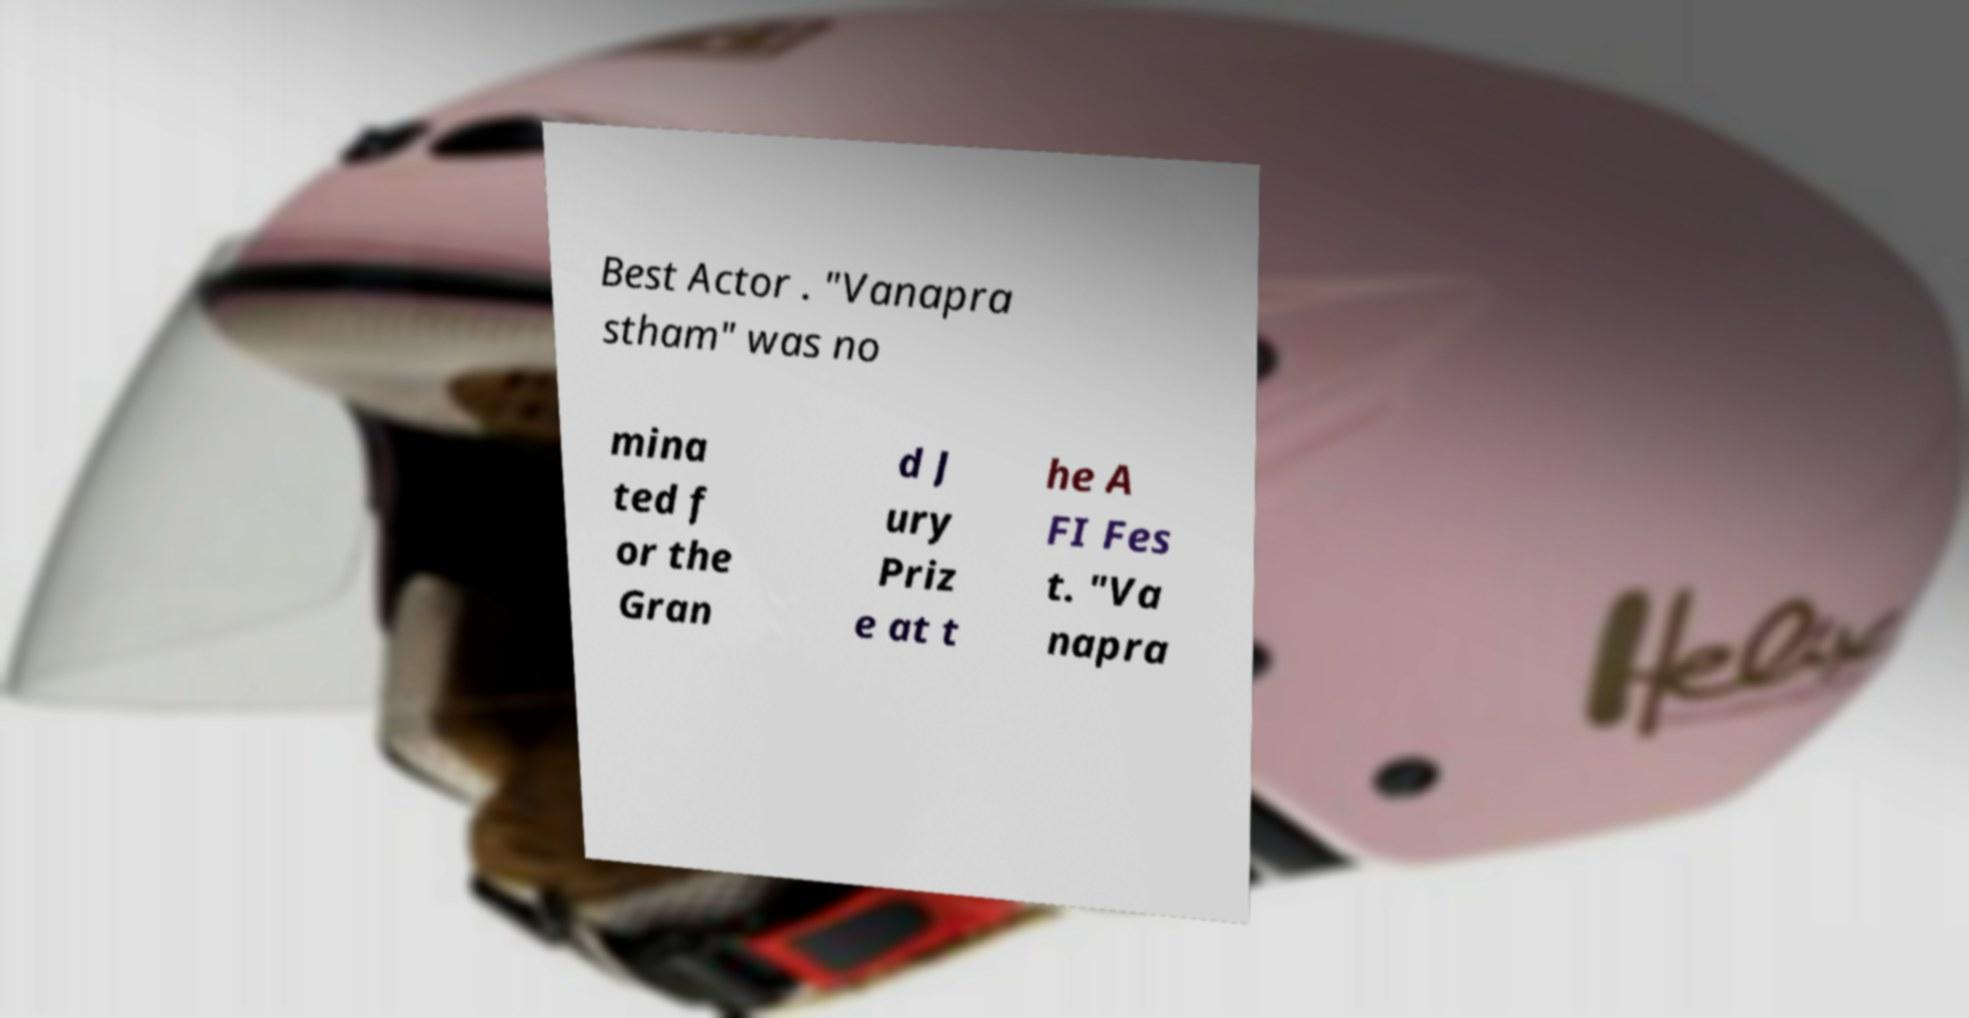Could you assist in decoding the text presented in this image and type it out clearly? Best Actor . "Vanapra stham" was no mina ted f or the Gran d J ury Priz e at t he A FI Fes t. "Va napra 